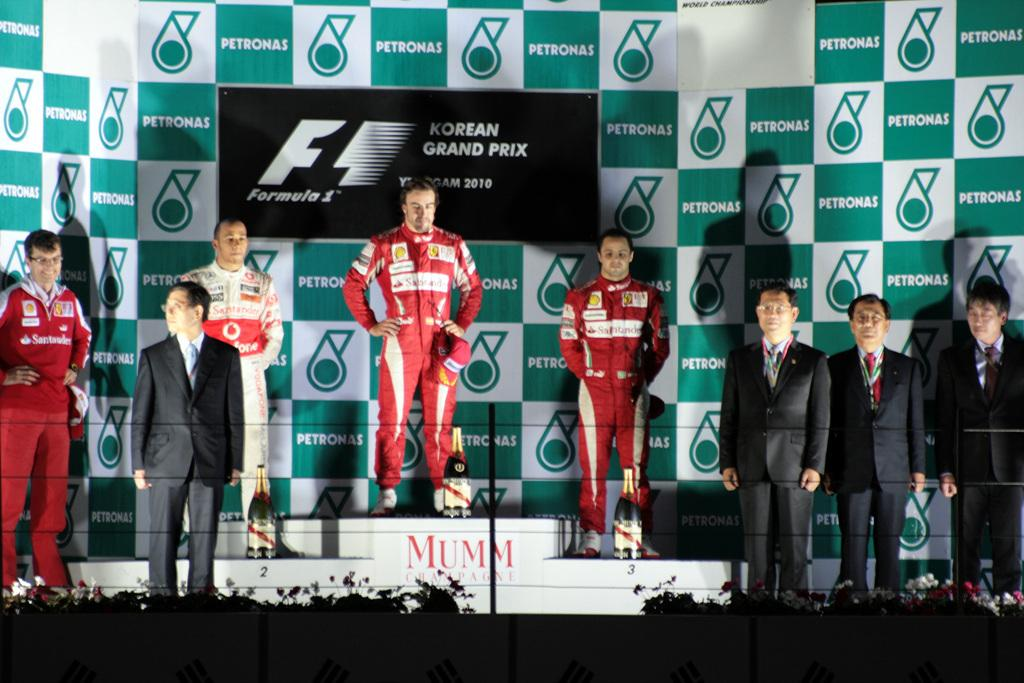Who or what can be seen in the image? There are people in the image. What else is present in the image besides the people? There are bottles, plants with flowers, and a banner in the image. Can you describe the plants with flowers in the image? The plants with flowers are unspecified, but they are present in the image. What might the banner be used for in the image? The purpose of the banner is not specified, but it is present in the image. What type of fowl can be seen wearing a locket in the image? There is no fowl or locket present in the image. What is the nature of the love depicted in the image? The image does not depict any love or romantic relationship; it features people, bottles, plants with flowers, and a banner. 